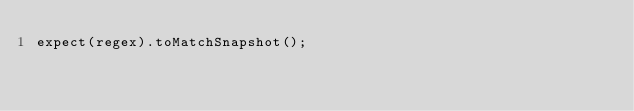Convert code to text. <code><loc_0><loc_0><loc_500><loc_500><_JavaScript_>expect(regex).toMatchSnapshot();
</code> 